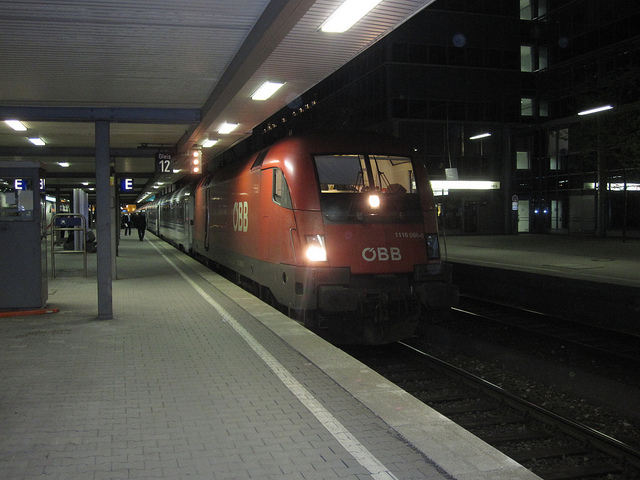Extract all visible text content from this image. BB E388 12 E 